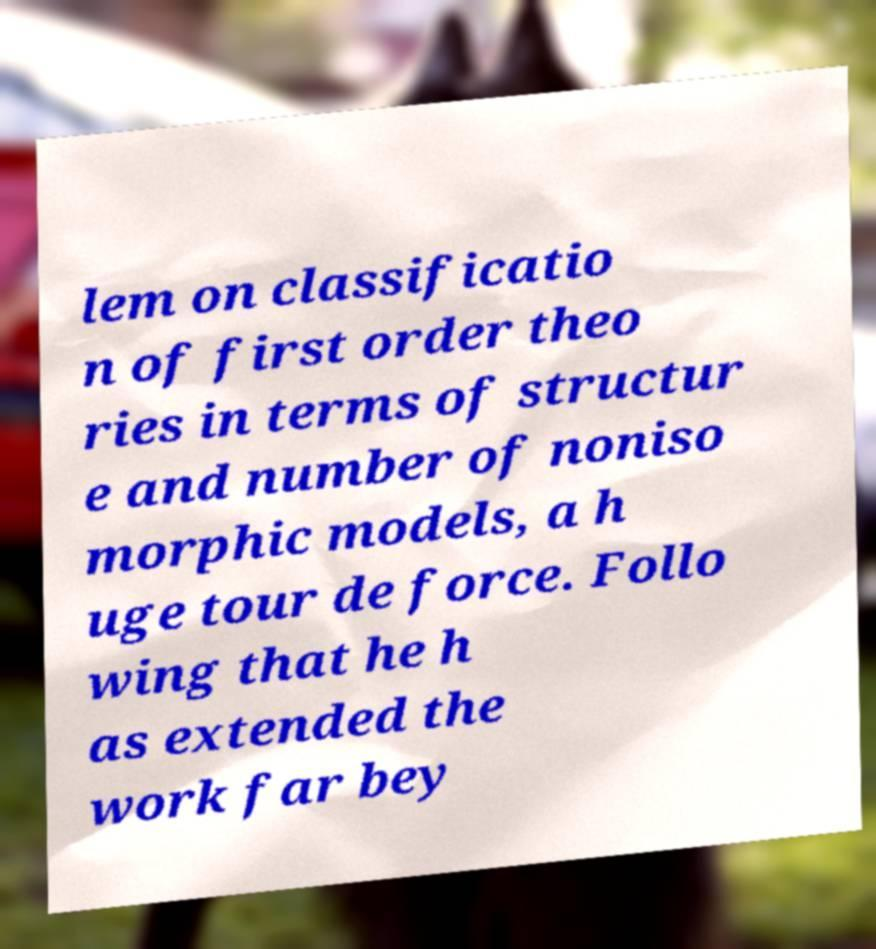Can you accurately transcribe the text from the provided image for me? lem on classificatio n of first order theo ries in terms of structur e and number of noniso morphic models, a h uge tour de force. Follo wing that he h as extended the work far bey 